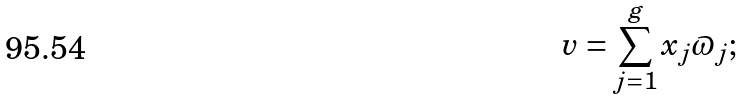<formula> <loc_0><loc_0><loc_500><loc_500>v = \sum _ { j = 1 } ^ { g } x _ { j } \varpi _ { j } ;</formula> 